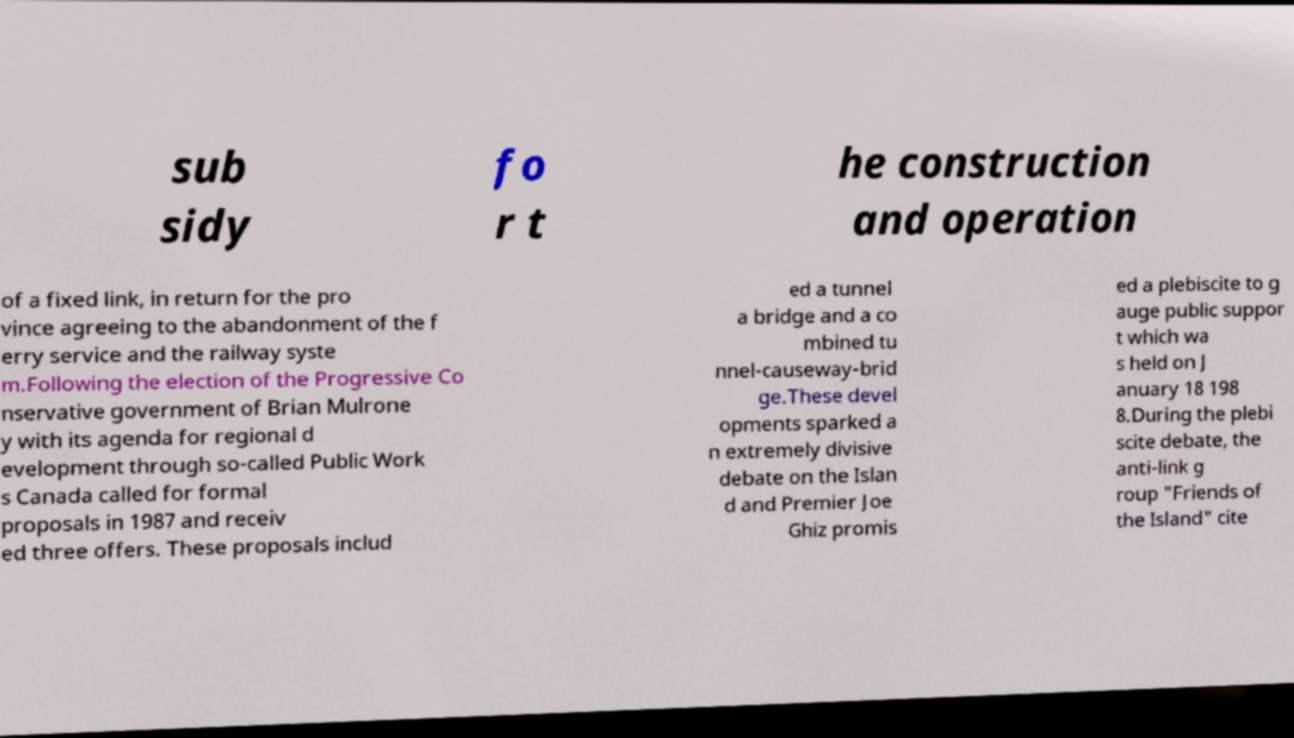Can you read and provide the text displayed in the image?This photo seems to have some interesting text. Can you extract and type it out for me? sub sidy fo r t he construction and operation of a fixed link, in return for the pro vince agreeing to the abandonment of the f erry service and the railway syste m.Following the election of the Progressive Co nservative government of Brian Mulrone y with its agenda for regional d evelopment through so-called Public Work s Canada called for formal proposals in 1987 and receiv ed three offers. These proposals includ ed a tunnel a bridge and a co mbined tu nnel-causeway-brid ge.These devel opments sparked a n extremely divisive debate on the Islan d and Premier Joe Ghiz promis ed a plebiscite to g auge public suppor t which wa s held on J anuary 18 198 8.During the plebi scite debate, the anti-link g roup "Friends of the Island" cite 